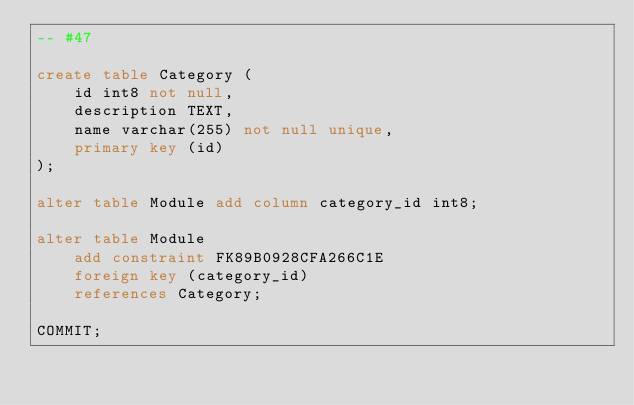Convert code to text. <code><loc_0><loc_0><loc_500><loc_500><_SQL_>-- #47
 
create table Category (
    id int8 not null,
    description TEXT,
    name varchar(255) not null unique,
    primary key (id)
);

alter table Module add column category_id int8;
 
alter table Module 
    add constraint FK89B0928CFA266C1E 
    foreign key (category_id) 
    references Category;

COMMIT;
</code> 